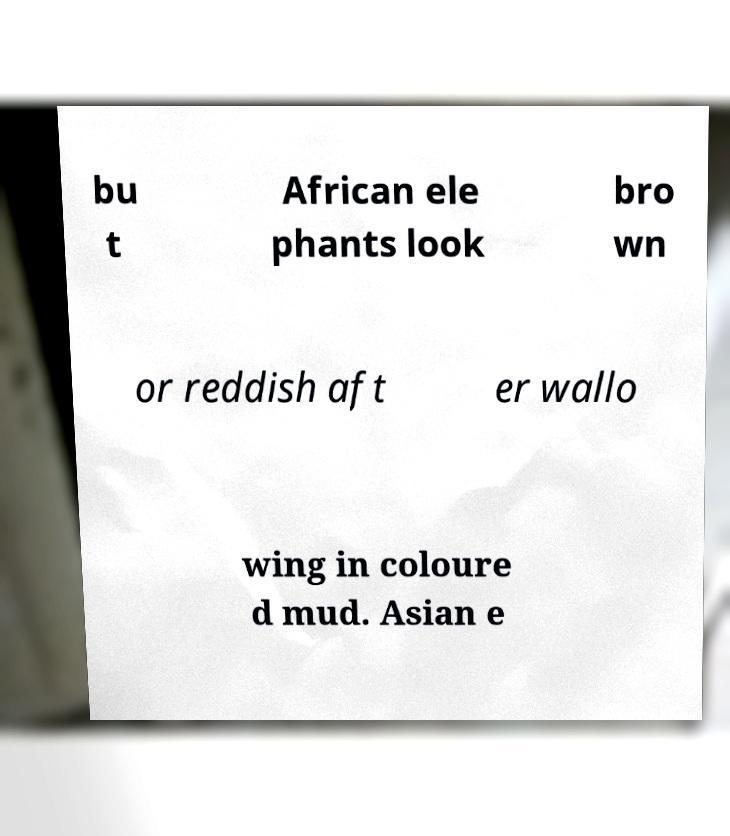Could you extract and type out the text from this image? bu t African ele phants look bro wn or reddish aft er wallo wing in coloure d mud. Asian e 